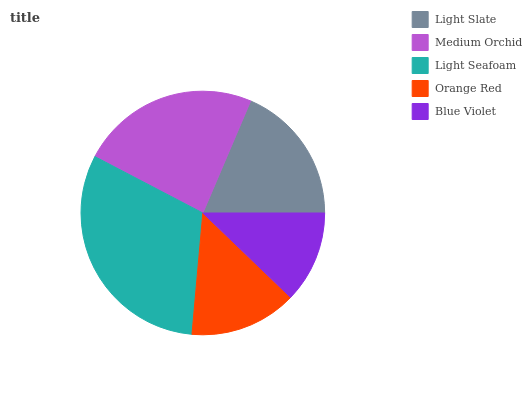Is Blue Violet the minimum?
Answer yes or no. Yes. Is Light Seafoam the maximum?
Answer yes or no. Yes. Is Medium Orchid the minimum?
Answer yes or no. No. Is Medium Orchid the maximum?
Answer yes or no. No. Is Medium Orchid greater than Light Slate?
Answer yes or no. Yes. Is Light Slate less than Medium Orchid?
Answer yes or no. Yes. Is Light Slate greater than Medium Orchid?
Answer yes or no. No. Is Medium Orchid less than Light Slate?
Answer yes or no. No. Is Light Slate the high median?
Answer yes or no. Yes. Is Light Slate the low median?
Answer yes or no. Yes. Is Light Seafoam the high median?
Answer yes or no. No. Is Medium Orchid the low median?
Answer yes or no. No. 